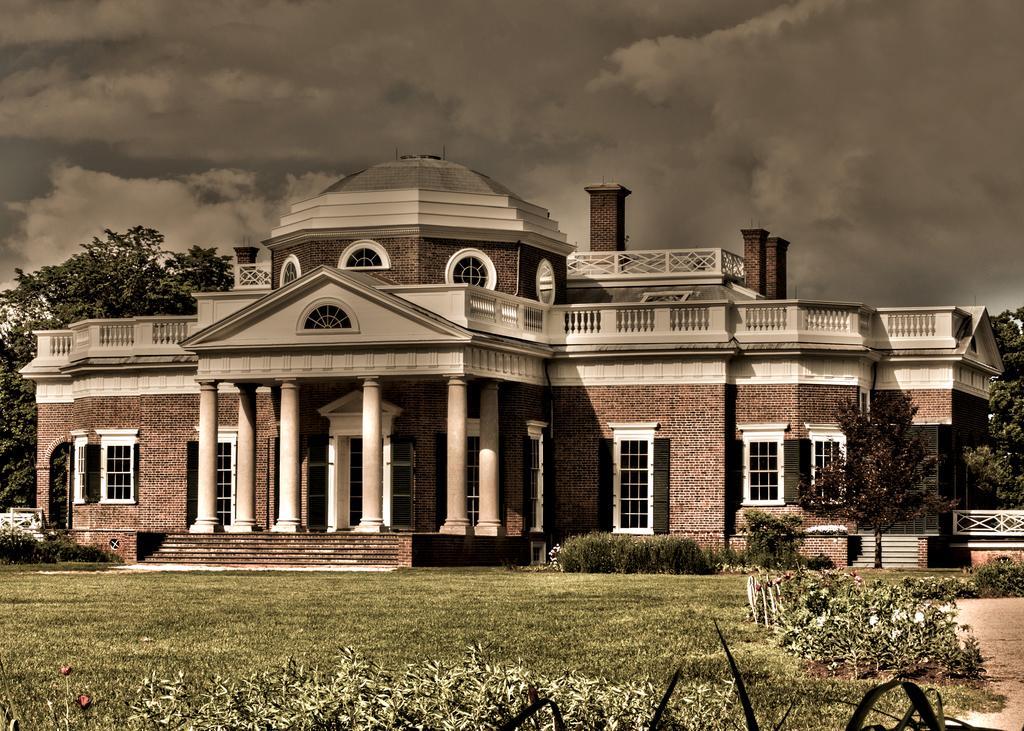Can you describe this image briefly? In this image there are bushes, grass in front of a building with stairs, around the building there are trees, at the top of the image there are clouds in the sky. 